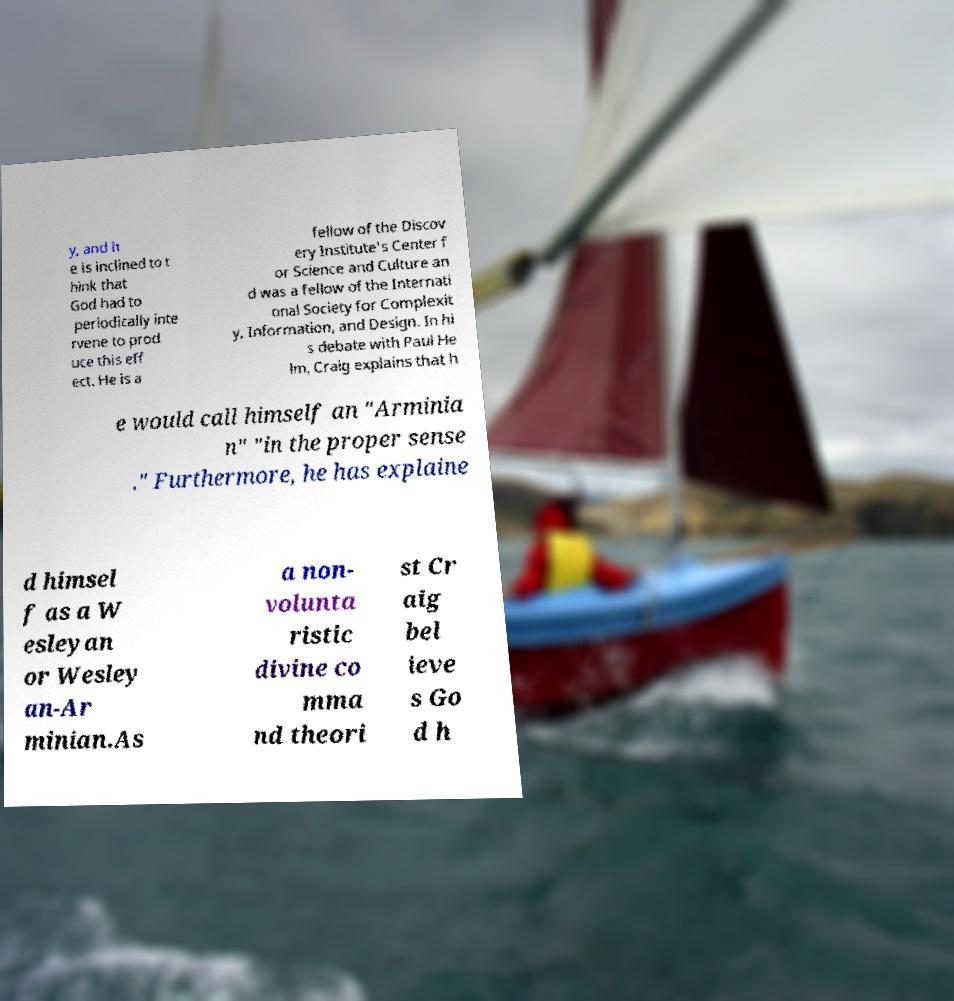Could you extract and type out the text from this image? y, and h e is inclined to t hink that God had to periodically inte rvene to prod uce this eff ect. He is a fellow of the Discov ery Institute's Center f or Science and Culture an d was a fellow of the Internati onal Society for Complexit y, Information, and Design. In hi s debate with Paul He lm, Craig explains that h e would call himself an "Arminia n" "in the proper sense ." Furthermore, he has explaine d himsel f as a W esleyan or Wesley an-Ar minian.As a non- volunta ristic divine co mma nd theori st Cr aig bel ieve s Go d h 